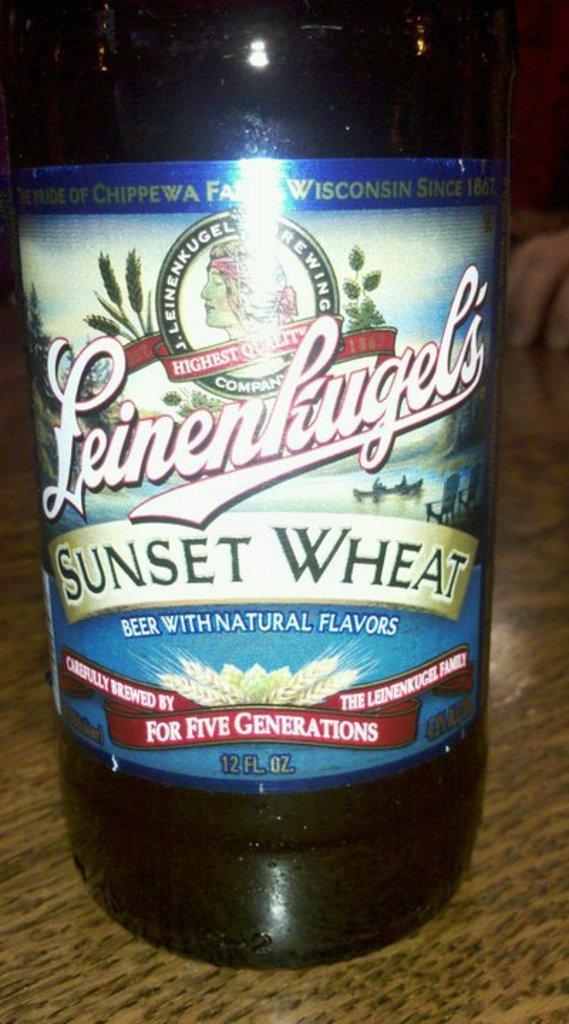How would you summarize this image in a sentence or two? On the table there is a bottle with a label. 